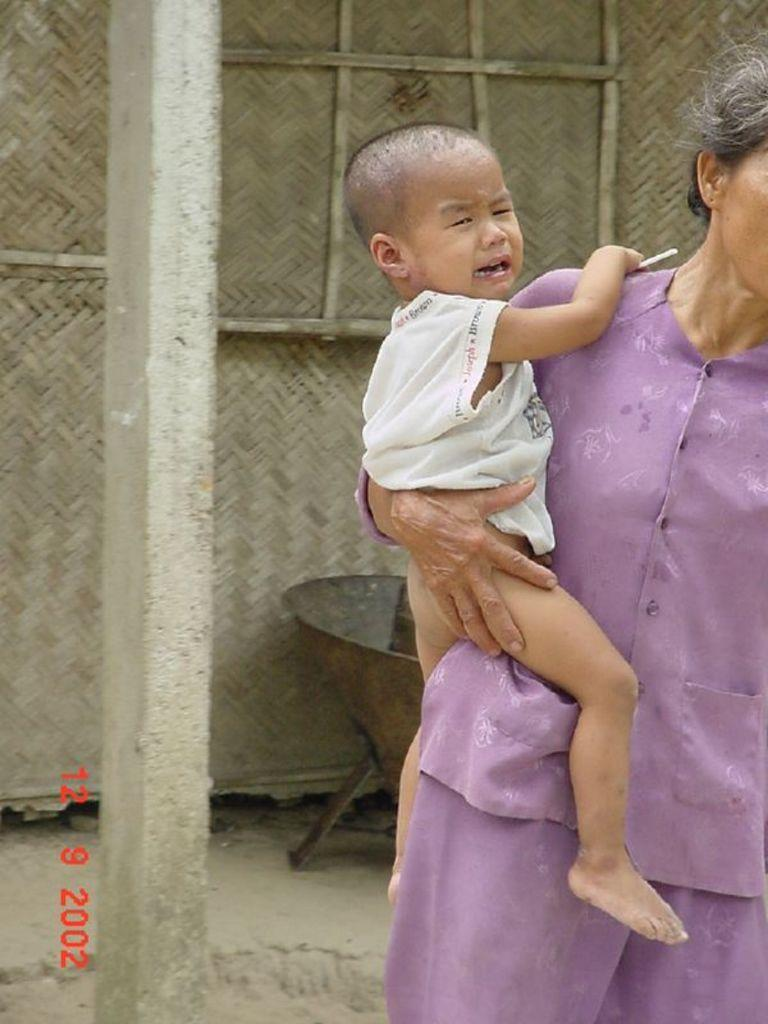What is the woman in the image holding? The woman is holding a baby in the image. What can be seen on the left side of the image? There is a pole on the left side of the image. What type of structure is visible in the background of the image? There is a thatched hut in the background of the image. What type of object can be seen in the background of the image? There is an iron object in the background of the image. What type of terrain is visible at the bottom of the image? There is sand at the bottom of the image. Can you see a flock of clams flying in the image? There are no clams or flying objects present in the image. 